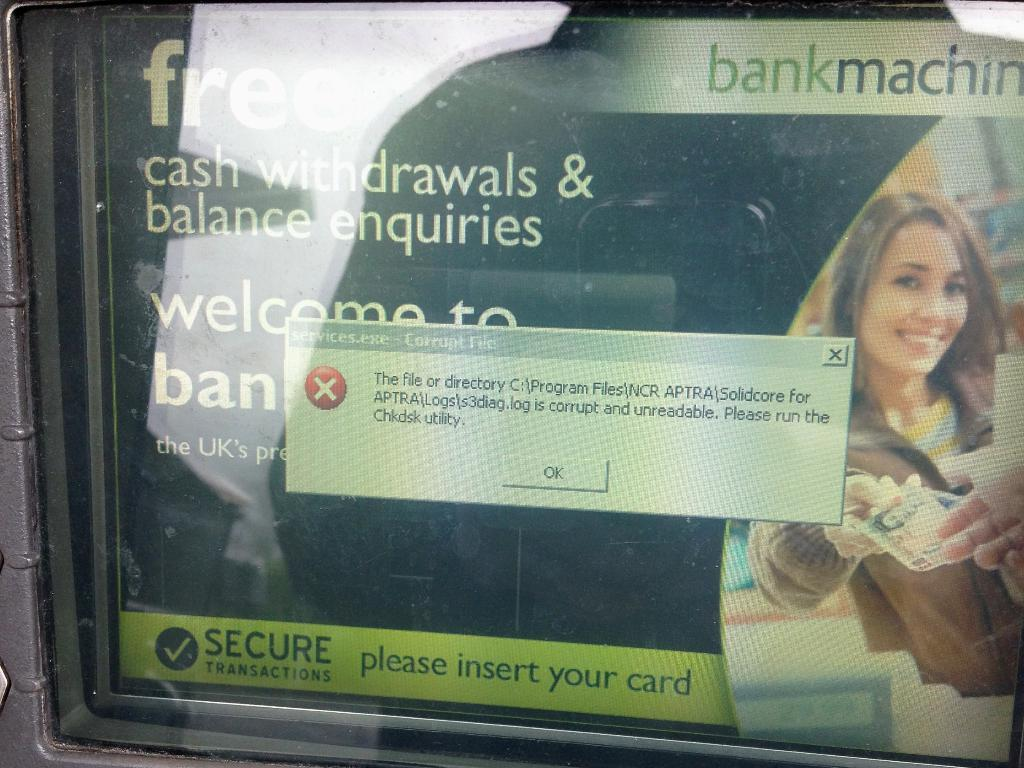What is displayed on the screen in the image? There is text and photos visible on the screen. Can you describe the content of the text on the screen? Unfortunately, the specific content of the text cannot be determined from the image alone. What type of photos are visible on the screen? The image does not provide enough detail to determine the type of photos displayed on the screen. How many bears are visible in the image? There are no bears present in the image. Is there a crook in the image? There is no crook present in the image. 